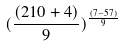Convert formula to latex. <formula><loc_0><loc_0><loc_500><loc_500>( \frac { ( 2 1 0 + 4 ) } { 9 } ) ^ { \frac { ( 7 - 5 7 ) } { 9 } }</formula> 